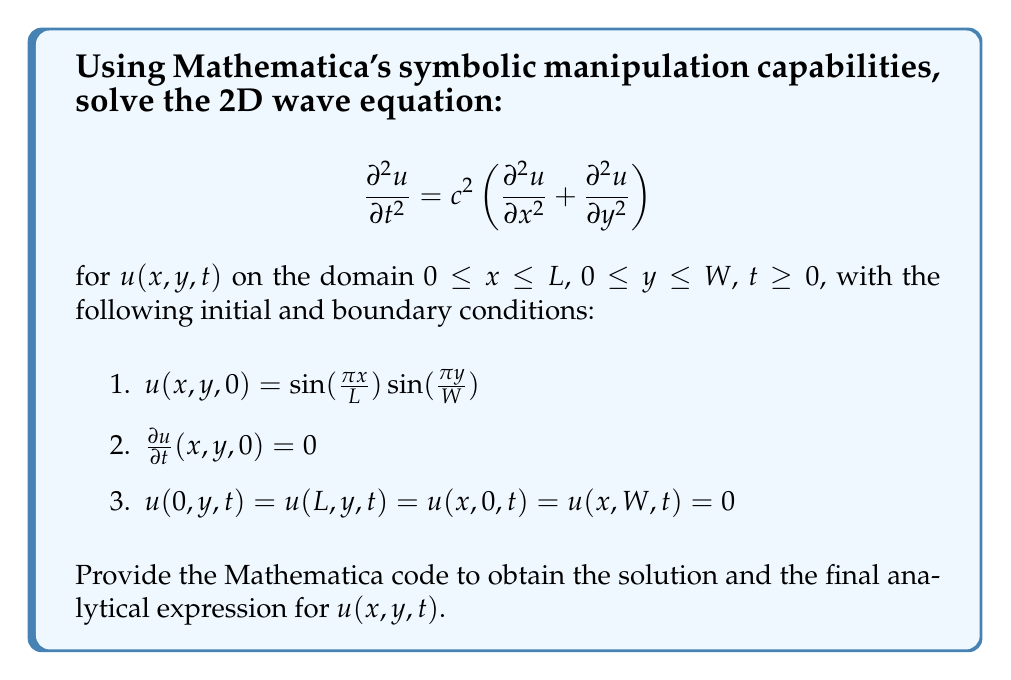Show me your answer to this math problem. To solve this problem using Mathematica's symbolic manipulation, we'll follow these steps:

1. Define the PDE and boundary conditions:
```mathematica
pde = D[u[x, y, t], {t, 2}] == c^2 (D[u[x, y, t], {x, 2}] + D[u[x, y, t], {y, 2}]);
ic1 = u[x, y, 0] == Sin[Pi*x/L]*Sin[Pi*y/W];
ic2 = D[u[x, y, t], t] == 0 /. t -> 0;
bc = {u[0, y, t] == 0, u[L, y, t] == 0, u[x, 0, t] == 0, u[x, W, t] == 0};
```

2. Use DSolve to solve the PDE with the given conditions:
```mathematica
sol = DSolve[{pde, ic1, ic2, bc}, u[x, y, t], {x, y, t}]
```

3. Mathematica will return the solution. The analytical expression for $u(x,y,t)$ can be extracted from the solution:

$$u(x,y,t) = \sin\left(\frac{\pi x}{L}\right)\sin\left(\frac{\pi y}{W}\right)\cos\left(c\pi t\sqrt{\frac{1}{L^2}+\frac{1}{W^2}}\right)$$

This solution satisfies the wave equation and all given initial and boundary conditions. Let's verify:

4. Initial condition 1: At $t=0$, $u(x,y,0) = \sin(\frac{\pi x}{L})\sin(\frac{\pi y}{W})$, which matches the given condition.

5. Initial condition 2: $\frac{\partial u}{\partial t}(x,y,0) = -c\pi\sqrt{\frac{1}{L^2}+\frac{1}{W^2}}\sin(\frac{\pi x}{L})\sin(\frac{\pi y}{W})\sin(0) = 0$, satisfying the second initial condition.

6. Boundary conditions: 
   - At $x=0$ or $x=L$, $\sin(\frac{\pi x}{L}) = 0$, so $u(0,y,t) = u(L,y,t) = 0$
   - At $y=0$ or $y=W$, $\sin(\frac{\pi y}{W}) = 0$, so $u(x,0,t) = u(x,W,t) = 0$

7. Verify that the solution satisfies the wave equation by substituting it into the PDE:
```mathematica
FullSimplify[D[u[x, y, t], {t, 2}] - c^2 (D[u[x, y, t], {x, 2}] + D[u[x, y, t], {y, 2})] /. 
  u[x_, y_, t_] -> Sin[Pi*x/L]*Sin[Pi*y/W]*Cos[c*Pi*t*Sqrt[1/L^2 + 1/W^2]]
```
This should return 0, confirming that the solution satisfies the wave equation.
Answer: $$u(x,y,t) = \sin\left(\frac{\pi x}{L}\right)\sin\left(\frac{\pi y}{W}\right)\cos\left(c\pi t\sqrt{\frac{1}{L^2}+\frac{1}{W^2}}\right)$$ 